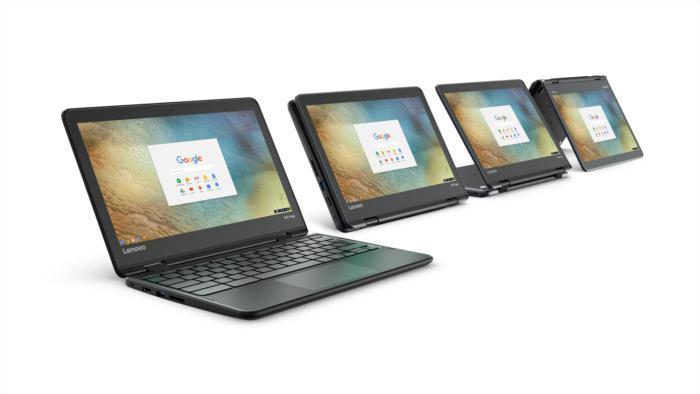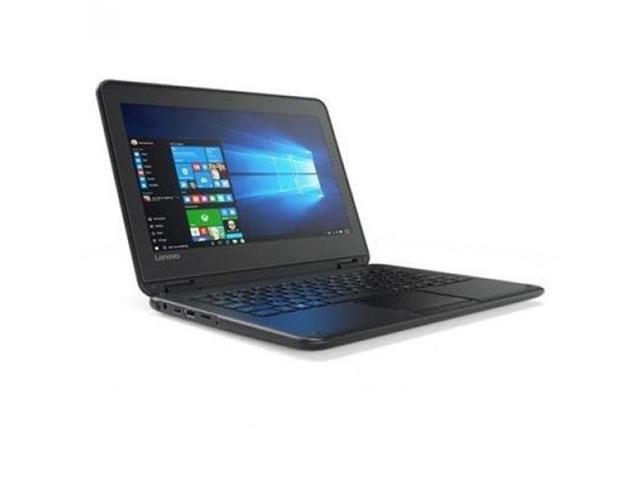The first image is the image on the left, the second image is the image on the right. Assess this claim about the two images: "There are more computers in the image on the left.". Correct or not? Answer yes or no. Yes. The first image is the image on the left, the second image is the image on the right. Analyze the images presented: Is the assertion "The combined images include at least three laptops that are open with the screen not inverted." valid? Answer yes or no. Yes. 